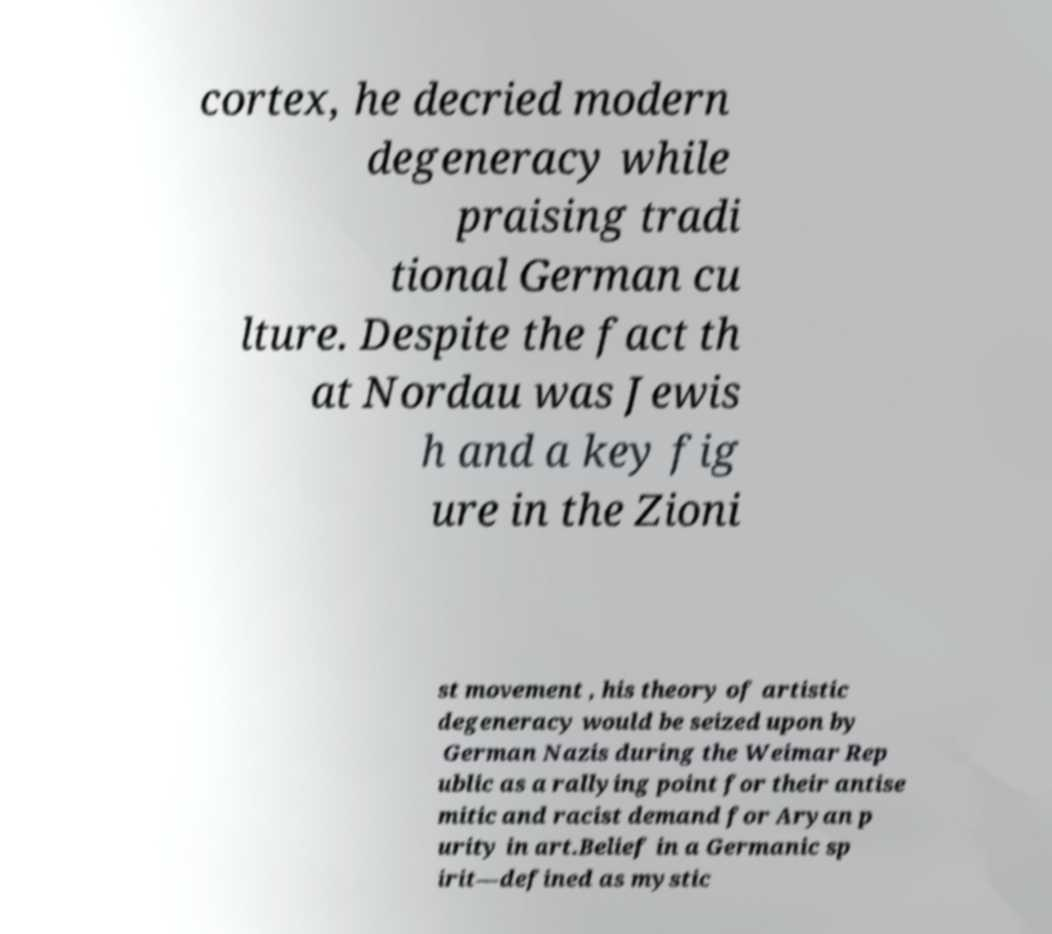For documentation purposes, I need the text within this image transcribed. Could you provide that? cortex, he decried modern degeneracy while praising tradi tional German cu lture. Despite the fact th at Nordau was Jewis h and a key fig ure in the Zioni st movement , his theory of artistic degeneracy would be seized upon by German Nazis during the Weimar Rep ublic as a rallying point for their antise mitic and racist demand for Aryan p urity in art.Belief in a Germanic sp irit—defined as mystic 